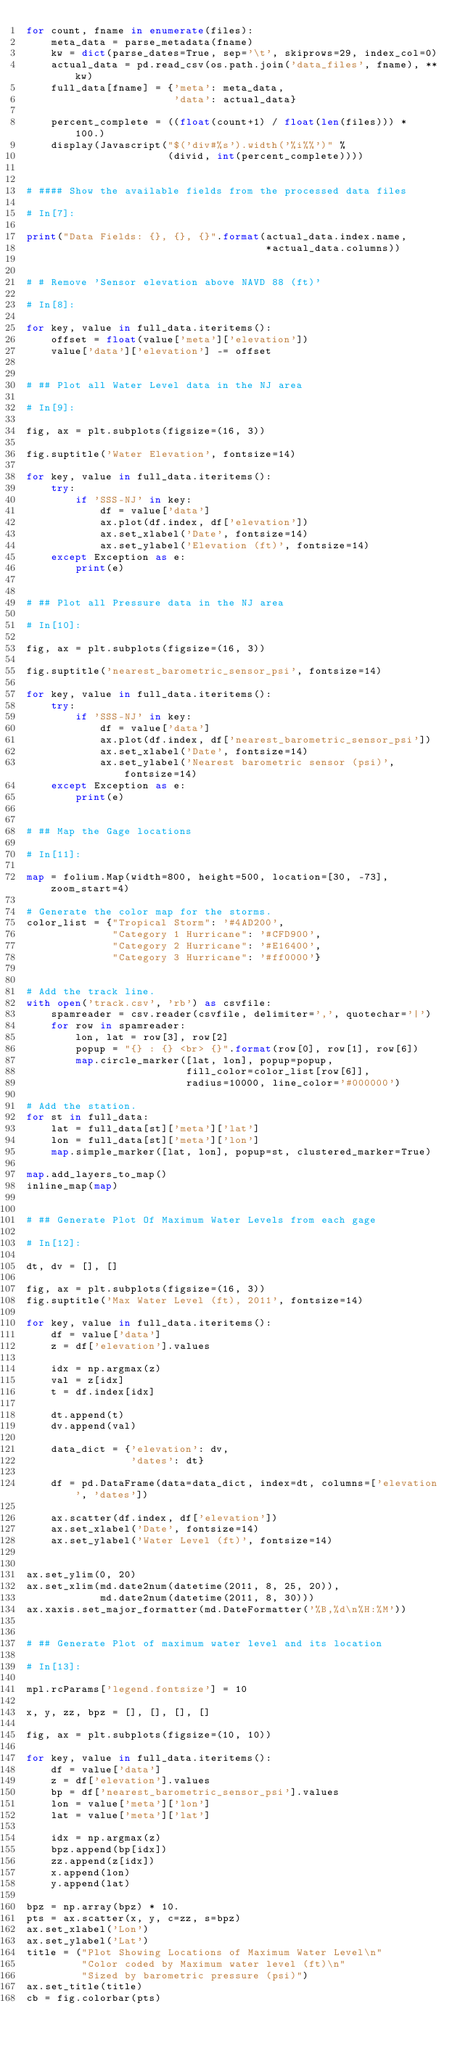Convert code to text. <code><loc_0><loc_0><loc_500><loc_500><_Python_>for count, fname in enumerate(files):
    meta_data = parse_metadata(fname)
    kw = dict(parse_dates=True, sep='\t', skiprows=29, index_col=0)
    actual_data = pd.read_csv(os.path.join('data_files', fname), **kw)
    full_data[fname] = {'meta': meta_data,
                        'data': actual_data}
    
    percent_complete = ((float(count+1) / float(len(files))) * 100.)
    display(Javascript("$('div#%s').width('%i%%')" %
                       (divid, int(percent_complete))))


# #### Show the available fields from the processed data files

# In[7]:

print("Data Fields: {}, {}, {}".format(actual_data.index.name,
                                       *actual_data.columns))


# # Remove 'Sensor elevation above NAVD 88 (ft)'

# In[8]:

for key, value in full_data.iteritems():
    offset = float(value['meta']['elevation'])
    value['data']['elevation'] -= offset


# ## Plot all Water Level data in the NJ area

# In[9]:

fig, ax = plt.subplots(figsize=(16, 3))

fig.suptitle('Water Elevation', fontsize=14)

for key, value in full_data.iteritems():
    try:
        if 'SSS-NJ' in key:
            df = value['data']                     
            ax.plot(df.index, df['elevation'])
            ax.set_xlabel('Date', fontsize=14)
            ax.set_ylabel('Elevation (ft)', fontsize=14) 
    except Exception as e:
        print(e)


# ## Plot all Pressure data in the NJ area

# In[10]:

fig, ax = plt.subplots(figsize=(16, 3))

fig.suptitle('nearest_barometric_sensor_psi', fontsize=14)

for key, value in full_data.iteritems():
    try:
        if 'SSS-NJ' in key:
            df = value['data']                     
            ax.plot(df.index, df['nearest_barometric_sensor_psi'])
            ax.set_xlabel('Date', fontsize=14)
            ax.set_ylabel('Nearest barometric sensor (psi)', fontsize=14) 
    except Exception as e:
        print(e)


# ## Map the Gage locations

# In[11]:

map = folium.Map(width=800, height=500, location=[30, -73], zoom_start=4)

# Generate the color map for the storms.
color_list = {"Tropical Storm": '#4AD200',
              "Category 1 Hurricane": '#CFD900',
              "Category 2 Hurricane": '#E16400',
              "Category 3 Hurricane": '#ff0000'}


# Add the track line.
with open('track.csv', 'rb') as csvfile:
    spamreader = csv.reader(csvfile, delimiter=',', quotechar='|')
    for row in spamreader:
        lon, lat = row[3], row[2]
        popup = "{} : {} <br> {}".format(row[0], row[1], row[6])
        map.circle_marker([lat, lon], popup=popup,
                          fill_color=color_list[row[6]],
                          radius=10000, line_color='#000000')

# Add the station.
for st in full_data:
    lat = full_data[st]['meta']['lat']
    lon = full_data[st]['meta']['lon']
    map.simple_marker([lat, lon], popup=st, clustered_marker=True)    

map.add_layers_to_map()
inline_map(map)


# ## Generate Plot Of Maximum Water Levels from each gage

# In[12]:

dt, dv = [], []

fig, ax = plt.subplots(figsize=(16, 3))
fig.suptitle('Max Water Level (ft), 2011', fontsize=14)

for key, value in full_data.iteritems():
    df = value['data']                     
    z = df['elevation'].values
    
    idx = np.argmax(z)
    val = z[idx]
    t = df.index[idx]
    
    dt.append(t)
    dv.append(val)
    
    data_dict = {'elevation': dv,
                 'dates': dt}
    
    df = pd.DataFrame(data=data_dict, index=dt, columns=['elevation', 'dates'])   
    
    ax.scatter(df.index, df['elevation'])
    ax.set_xlabel('Date', fontsize=14)
    ax.set_ylabel('Water Level (ft)', fontsize=14) 


ax.set_ylim(0, 20)
ax.set_xlim(md.date2num(datetime(2011, 8, 25, 20)),
            md.date2num(datetime(2011, 8, 30)))
ax.xaxis.set_major_formatter(md.DateFormatter('%B,%d\n%H:%M'))


# ## Generate Plot of maximum water level and its location

# In[13]:

mpl.rcParams['legend.fontsize'] = 10

x, y, zz, bpz = [], [], [], []

fig, ax = plt.subplots(figsize=(10, 10))

for key, value in full_data.iteritems():
    df = value['data']
    z = df['elevation'].values
    bp = df['nearest_barometric_sensor_psi'].values
    lon = value['meta']['lon']
    lat = value['meta']['lat']
    
    idx = np.argmax(z)
    bpz.append(bp[idx])
    zz.append(z[idx])
    x.append(lon)
    y.append(lat)

bpz = np.array(bpz) * 10.
pts = ax.scatter(x, y, c=zz, s=bpz)
ax.set_xlabel('Lon')
ax.set_ylabel('Lat')
title = ("Plot Showing Locations of Maximum Water Level\n"
         "Color coded by Maximum water level (ft)\n"
         "Sized by barometric pressure (psi)")
ax.set_title(title)
cb = fig.colorbar(pts)

</code> 